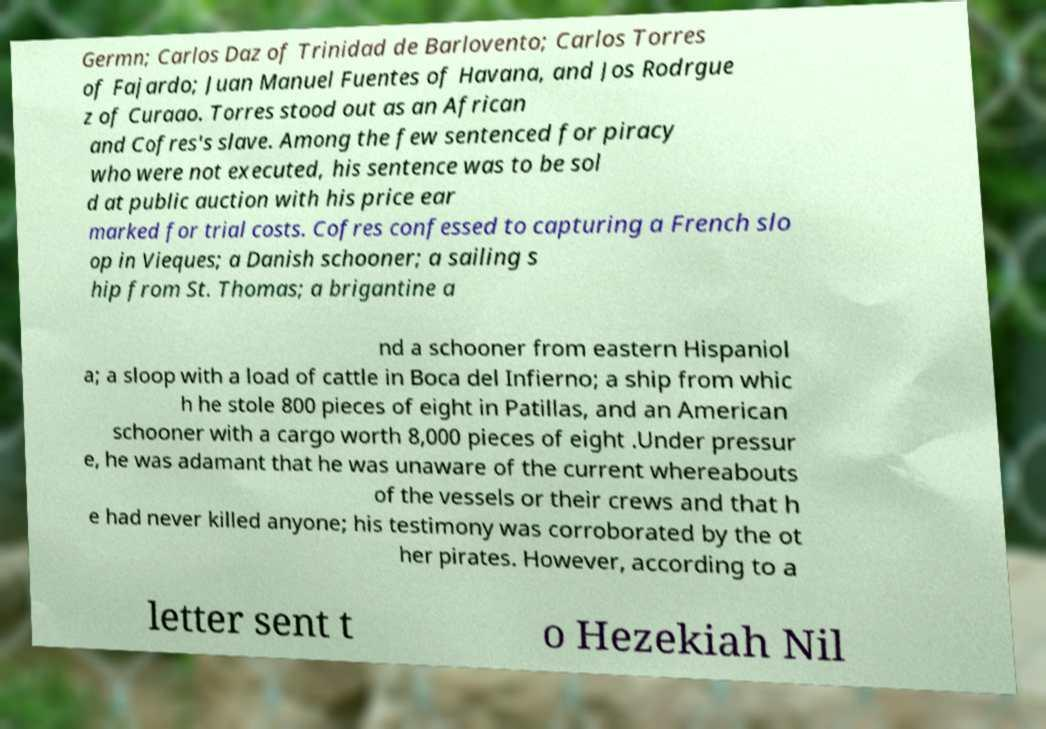Can you read and provide the text displayed in the image?This photo seems to have some interesting text. Can you extract and type it out for me? Germn; Carlos Daz of Trinidad de Barlovento; Carlos Torres of Fajardo; Juan Manuel Fuentes of Havana, and Jos Rodrgue z of Curaao. Torres stood out as an African and Cofres's slave. Among the few sentenced for piracy who were not executed, his sentence was to be sol d at public auction with his price ear marked for trial costs. Cofres confessed to capturing a French slo op in Vieques; a Danish schooner; a sailing s hip from St. Thomas; a brigantine a nd a schooner from eastern Hispaniol a; a sloop with a load of cattle in Boca del Infierno; a ship from whic h he stole 800 pieces of eight in Patillas, and an American schooner with a cargo worth 8,000 pieces of eight .Under pressur e, he was adamant that he was unaware of the current whereabouts of the vessels or their crews and that h e had never killed anyone; his testimony was corroborated by the ot her pirates. However, according to a letter sent t o Hezekiah Nil 